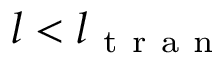<formula> <loc_0><loc_0><loc_500><loc_500>l < l _ { t r a n }</formula> 